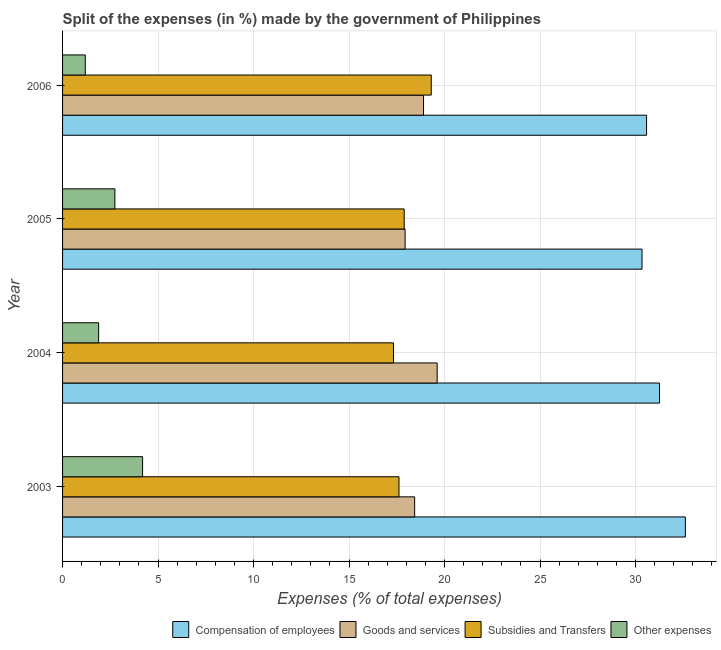How many different coloured bars are there?
Make the answer very short. 4. How many groups of bars are there?
Ensure brevity in your answer.  4. Are the number of bars on each tick of the Y-axis equal?
Give a very brief answer. Yes. What is the percentage of amount spent on goods and services in 2004?
Ensure brevity in your answer.  19.61. Across all years, what is the maximum percentage of amount spent on other expenses?
Offer a terse response. 4.19. Across all years, what is the minimum percentage of amount spent on subsidies?
Give a very brief answer. 17.33. In which year was the percentage of amount spent on compensation of employees maximum?
Make the answer very short. 2003. In which year was the percentage of amount spent on other expenses minimum?
Make the answer very short. 2006. What is the total percentage of amount spent on compensation of employees in the graph?
Make the answer very short. 124.78. What is the difference between the percentage of amount spent on goods and services in 2005 and that in 2006?
Your answer should be compact. -0.96. What is the difference between the percentage of amount spent on compensation of employees in 2003 and the percentage of amount spent on subsidies in 2006?
Your answer should be compact. 13.3. What is the average percentage of amount spent on subsidies per year?
Your answer should be compact. 18.03. In the year 2003, what is the difference between the percentage of amount spent on other expenses and percentage of amount spent on subsidies?
Provide a short and direct response. -13.42. What is the ratio of the percentage of amount spent on compensation of employees in 2003 to that in 2005?
Offer a very short reply. 1.07. What is the difference between the highest and the second highest percentage of amount spent on other expenses?
Keep it short and to the point. 1.45. In how many years, is the percentage of amount spent on other expenses greater than the average percentage of amount spent on other expenses taken over all years?
Your response must be concise. 2. Is the sum of the percentage of amount spent on goods and services in 2005 and 2006 greater than the maximum percentage of amount spent on compensation of employees across all years?
Make the answer very short. Yes. What does the 4th bar from the top in 2006 represents?
Your response must be concise. Compensation of employees. What does the 3rd bar from the bottom in 2006 represents?
Keep it short and to the point. Subsidies and Transfers. How many bars are there?
Give a very brief answer. 16. Are all the bars in the graph horizontal?
Ensure brevity in your answer.  Yes. How many years are there in the graph?
Keep it short and to the point. 4. What is the difference between two consecutive major ticks on the X-axis?
Offer a very short reply. 5. Does the graph contain any zero values?
Provide a succinct answer. No. Does the graph contain grids?
Give a very brief answer. Yes. What is the title of the graph?
Your answer should be compact. Split of the expenses (in %) made by the government of Philippines. Does "Miscellaneous expenses" appear as one of the legend labels in the graph?
Offer a very short reply. No. What is the label or title of the X-axis?
Your response must be concise. Expenses (% of total expenses). What is the label or title of the Y-axis?
Keep it short and to the point. Year. What is the Expenses (% of total expenses) of Compensation of employees in 2003?
Offer a terse response. 32.61. What is the Expenses (% of total expenses) of Goods and services in 2003?
Offer a terse response. 18.44. What is the Expenses (% of total expenses) of Subsidies and Transfers in 2003?
Offer a terse response. 17.62. What is the Expenses (% of total expenses) of Other expenses in 2003?
Provide a succinct answer. 4.19. What is the Expenses (% of total expenses) of Compensation of employees in 2004?
Ensure brevity in your answer.  31.26. What is the Expenses (% of total expenses) of Goods and services in 2004?
Make the answer very short. 19.61. What is the Expenses (% of total expenses) in Subsidies and Transfers in 2004?
Give a very brief answer. 17.33. What is the Expenses (% of total expenses) in Other expenses in 2004?
Provide a succinct answer. 1.89. What is the Expenses (% of total expenses) of Compensation of employees in 2005?
Make the answer very short. 30.34. What is the Expenses (% of total expenses) in Goods and services in 2005?
Provide a succinct answer. 17.94. What is the Expenses (% of total expenses) of Subsidies and Transfers in 2005?
Your answer should be very brief. 17.89. What is the Expenses (% of total expenses) in Other expenses in 2005?
Your response must be concise. 2.74. What is the Expenses (% of total expenses) of Compensation of employees in 2006?
Give a very brief answer. 30.58. What is the Expenses (% of total expenses) of Goods and services in 2006?
Your response must be concise. 18.9. What is the Expenses (% of total expenses) of Subsidies and Transfers in 2006?
Offer a terse response. 19.31. What is the Expenses (% of total expenses) in Other expenses in 2006?
Provide a short and direct response. 1.19. Across all years, what is the maximum Expenses (% of total expenses) in Compensation of employees?
Offer a very short reply. 32.61. Across all years, what is the maximum Expenses (% of total expenses) of Goods and services?
Keep it short and to the point. 19.61. Across all years, what is the maximum Expenses (% of total expenses) in Subsidies and Transfers?
Offer a very short reply. 19.31. Across all years, what is the maximum Expenses (% of total expenses) of Other expenses?
Your response must be concise. 4.19. Across all years, what is the minimum Expenses (% of total expenses) in Compensation of employees?
Your response must be concise. 30.34. Across all years, what is the minimum Expenses (% of total expenses) of Goods and services?
Make the answer very short. 17.94. Across all years, what is the minimum Expenses (% of total expenses) in Subsidies and Transfers?
Make the answer very short. 17.33. Across all years, what is the minimum Expenses (% of total expenses) in Other expenses?
Your response must be concise. 1.19. What is the total Expenses (% of total expenses) in Compensation of employees in the graph?
Keep it short and to the point. 124.78. What is the total Expenses (% of total expenses) in Goods and services in the graph?
Offer a terse response. 74.88. What is the total Expenses (% of total expenses) of Subsidies and Transfers in the graph?
Your answer should be compact. 72.13. What is the total Expenses (% of total expenses) in Other expenses in the graph?
Offer a very short reply. 10.01. What is the difference between the Expenses (% of total expenses) of Compensation of employees in 2003 and that in 2004?
Keep it short and to the point. 1.35. What is the difference between the Expenses (% of total expenses) of Goods and services in 2003 and that in 2004?
Offer a very short reply. -1.18. What is the difference between the Expenses (% of total expenses) of Subsidies and Transfers in 2003 and that in 2004?
Offer a terse response. 0.29. What is the difference between the Expenses (% of total expenses) of Other expenses in 2003 and that in 2004?
Offer a terse response. 2.3. What is the difference between the Expenses (% of total expenses) in Compensation of employees in 2003 and that in 2005?
Keep it short and to the point. 2.27. What is the difference between the Expenses (% of total expenses) in Goods and services in 2003 and that in 2005?
Ensure brevity in your answer.  0.5. What is the difference between the Expenses (% of total expenses) of Subsidies and Transfers in 2003 and that in 2005?
Make the answer very short. -0.27. What is the difference between the Expenses (% of total expenses) of Other expenses in 2003 and that in 2005?
Give a very brief answer. 1.45. What is the difference between the Expenses (% of total expenses) of Compensation of employees in 2003 and that in 2006?
Provide a short and direct response. 2.03. What is the difference between the Expenses (% of total expenses) of Goods and services in 2003 and that in 2006?
Give a very brief answer. -0.46. What is the difference between the Expenses (% of total expenses) in Subsidies and Transfers in 2003 and that in 2006?
Your answer should be very brief. -1.69. What is the difference between the Expenses (% of total expenses) in Other expenses in 2003 and that in 2006?
Give a very brief answer. 3. What is the difference between the Expenses (% of total expenses) of Compensation of employees in 2004 and that in 2005?
Make the answer very short. 0.92. What is the difference between the Expenses (% of total expenses) in Goods and services in 2004 and that in 2005?
Offer a terse response. 1.68. What is the difference between the Expenses (% of total expenses) in Subsidies and Transfers in 2004 and that in 2005?
Your answer should be compact. -0.56. What is the difference between the Expenses (% of total expenses) of Other expenses in 2004 and that in 2005?
Offer a very short reply. -0.85. What is the difference between the Expenses (% of total expenses) in Compensation of employees in 2004 and that in 2006?
Provide a succinct answer. 0.68. What is the difference between the Expenses (% of total expenses) of Goods and services in 2004 and that in 2006?
Provide a succinct answer. 0.71. What is the difference between the Expenses (% of total expenses) in Subsidies and Transfers in 2004 and that in 2006?
Your answer should be compact. -1.98. What is the difference between the Expenses (% of total expenses) in Other expenses in 2004 and that in 2006?
Keep it short and to the point. 0.7. What is the difference between the Expenses (% of total expenses) of Compensation of employees in 2005 and that in 2006?
Give a very brief answer. -0.24. What is the difference between the Expenses (% of total expenses) in Goods and services in 2005 and that in 2006?
Make the answer very short. -0.97. What is the difference between the Expenses (% of total expenses) of Subsidies and Transfers in 2005 and that in 2006?
Your answer should be very brief. -1.42. What is the difference between the Expenses (% of total expenses) of Other expenses in 2005 and that in 2006?
Give a very brief answer. 1.55. What is the difference between the Expenses (% of total expenses) in Compensation of employees in 2003 and the Expenses (% of total expenses) in Goods and services in 2004?
Your answer should be compact. 13. What is the difference between the Expenses (% of total expenses) in Compensation of employees in 2003 and the Expenses (% of total expenses) in Subsidies and Transfers in 2004?
Your answer should be compact. 15.28. What is the difference between the Expenses (% of total expenses) in Compensation of employees in 2003 and the Expenses (% of total expenses) in Other expenses in 2004?
Give a very brief answer. 30.72. What is the difference between the Expenses (% of total expenses) of Goods and services in 2003 and the Expenses (% of total expenses) of Subsidies and Transfers in 2004?
Your response must be concise. 1.11. What is the difference between the Expenses (% of total expenses) of Goods and services in 2003 and the Expenses (% of total expenses) of Other expenses in 2004?
Give a very brief answer. 16.55. What is the difference between the Expenses (% of total expenses) of Subsidies and Transfers in 2003 and the Expenses (% of total expenses) of Other expenses in 2004?
Provide a succinct answer. 15.73. What is the difference between the Expenses (% of total expenses) in Compensation of employees in 2003 and the Expenses (% of total expenses) in Goods and services in 2005?
Your response must be concise. 14.67. What is the difference between the Expenses (% of total expenses) of Compensation of employees in 2003 and the Expenses (% of total expenses) of Subsidies and Transfers in 2005?
Provide a succinct answer. 14.72. What is the difference between the Expenses (% of total expenses) in Compensation of employees in 2003 and the Expenses (% of total expenses) in Other expenses in 2005?
Provide a succinct answer. 29.87. What is the difference between the Expenses (% of total expenses) of Goods and services in 2003 and the Expenses (% of total expenses) of Subsidies and Transfers in 2005?
Provide a succinct answer. 0.55. What is the difference between the Expenses (% of total expenses) of Goods and services in 2003 and the Expenses (% of total expenses) of Other expenses in 2005?
Offer a very short reply. 15.7. What is the difference between the Expenses (% of total expenses) in Subsidies and Transfers in 2003 and the Expenses (% of total expenses) in Other expenses in 2005?
Provide a short and direct response. 14.88. What is the difference between the Expenses (% of total expenses) in Compensation of employees in 2003 and the Expenses (% of total expenses) in Goods and services in 2006?
Offer a terse response. 13.71. What is the difference between the Expenses (% of total expenses) of Compensation of employees in 2003 and the Expenses (% of total expenses) of Subsidies and Transfers in 2006?
Make the answer very short. 13.3. What is the difference between the Expenses (% of total expenses) in Compensation of employees in 2003 and the Expenses (% of total expenses) in Other expenses in 2006?
Your answer should be compact. 31.42. What is the difference between the Expenses (% of total expenses) in Goods and services in 2003 and the Expenses (% of total expenses) in Subsidies and Transfers in 2006?
Ensure brevity in your answer.  -0.87. What is the difference between the Expenses (% of total expenses) of Goods and services in 2003 and the Expenses (% of total expenses) of Other expenses in 2006?
Offer a very short reply. 17.25. What is the difference between the Expenses (% of total expenses) of Subsidies and Transfers in 2003 and the Expenses (% of total expenses) of Other expenses in 2006?
Give a very brief answer. 16.42. What is the difference between the Expenses (% of total expenses) of Compensation of employees in 2004 and the Expenses (% of total expenses) of Goods and services in 2005?
Your answer should be very brief. 13.32. What is the difference between the Expenses (% of total expenses) in Compensation of employees in 2004 and the Expenses (% of total expenses) in Subsidies and Transfers in 2005?
Make the answer very short. 13.37. What is the difference between the Expenses (% of total expenses) in Compensation of employees in 2004 and the Expenses (% of total expenses) in Other expenses in 2005?
Keep it short and to the point. 28.52. What is the difference between the Expenses (% of total expenses) in Goods and services in 2004 and the Expenses (% of total expenses) in Subsidies and Transfers in 2005?
Your response must be concise. 1.73. What is the difference between the Expenses (% of total expenses) in Goods and services in 2004 and the Expenses (% of total expenses) in Other expenses in 2005?
Give a very brief answer. 16.87. What is the difference between the Expenses (% of total expenses) of Subsidies and Transfers in 2004 and the Expenses (% of total expenses) of Other expenses in 2005?
Your answer should be very brief. 14.59. What is the difference between the Expenses (% of total expenses) in Compensation of employees in 2004 and the Expenses (% of total expenses) in Goods and services in 2006?
Make the answer very short. 12.36. What is the difference between the Expenses (% of total expenses) of Compensation of employees in 2004 and the Expenses (% of total expenses) of Subsidies and Transfers in 2006?
Ensure brevity in your answer.  11.95. What is the difference between the Expenses (% of total expenses) of Compensation of employees in 2004 and the Expenses (% of total expenses) of Other expenses in 2006?
Offer a very short reply. 30.07. What is the difference between the Expenses (% of total expenses) of Goods and services in 2004 and the Expenses (% of total expenses) of Subsidies and Transfers in 2006?
Offer a terse response. 0.31. What is the difference between the Expenses (% of total expenses) in Goods and services in 2004 and the Expenses (% of total expenses) in Other expenses in 2006?
Your answer should be compact. 18.42. What is the difference between the Expenses (% of total expenses) of Subsidies and Transfers in 2004 and the Expenses (% of total expenses) of Other expenses in 2006?
Make the answer very short. 16.14. What is the difference between the Expenses (% of total expenses) in Compensation of employees in 2005 and the Expenses (% of total expenses) in Goods and services in 2006?
Your response must be concise. 11.44. What is the difference between the Expenses (% of total expenses) in Compensation of employees in 2005 and the Expenses (% of total expenses) in Subsidies and Transfers in 2006?
Your answer should be compact. 11.03. What is the difference between the Expenses (% of total expenses) of Compensation of employees in 2005 and the Expenses (% of total expenses) of Other expenses in 2006?
Make the answer very short. 29.15. What is the difference between the Expenses (% of total expenses) in Goods and services in 2005 and the Expenses (% of total expenses) in Subsidies and Transfers in 2006?
Offer a very short reply. -1.37. What is the difference between the Expenses (% of total expenses) in Goods and services in 2005 and the Expenses (% of total expenses) in Other expenses in 2006?
Your response must be concise. 16.74. What is the difference between the Expenses (% of total expenses) of Subsidies and Transfers in 2005 and the Expenses (% of total expenses) of Other expenses in 2006?
Make the answer very short. 16.7. What is the average Expenses (% of total expenses) of Compensation of employees per year?
Your answer should be very brief. 31.2. What is the average Expenses (% of total expenses) in Goods and services per year?
Give a very brief answer. 18.72. What is the average Expenses (% of total expenses) in Subsidies and Transfers per year?
Your answer should be very brief. 18.03. What is the average Expenses (% of total expenses) in Other expenses per year?
Your answer should be compact. 2.5. In the year 2003, what is the difference between the Expenses (% of total expenses) of Compensation of employees and Expenses (% of total expenses) of Goods and services?
Give a very brief answer. 14.17. In the year 2003, what is the difference between the Expenses (% of total expenses) of Compensation of employees and Expenses (% of total expenses) of Subsidies and Transfers?
Ensure brevity in your answer.  14.99. In the year 2003, what is the difference between the Expenses (% of total expenses) in Compensation of employees and Expenses (% of total expenses) in Other expenses?
Make the answer very short. 28.42. In the year 2003, what is the difference between the Expenses (% of total expenses) of Goods and services and Expenses (% of total expenses) of Subsidies and Transfers?
Your answer should be compact. 0.82. In the year 2003, what is the difference between the Expenses (% of total expenses) of Goods and services and Expenses (% of total expenses) of Other expenses?
Provide a succinct answer. 14.24. In the year 2003, what is the difference between the Expenses (% of total expenses) in Subsidies and Transfers and Expenses (% of total expenses) in Other expenses?
Offer a very short reply. 13.42. In the year 2004, what is the difference between the Expenses (% of total expenses) of Compensation of employees and Expenses (% of total expenses) of Goods and services?
Keep it short and to the point. 11.64. In the year 2004, what is the difference between the Expenses (% of total expenses) of Compensation of employees and Expenses (% of total expenses) of Subsidies and Transfers?
Make the answer very short. 13.93. In the year 2004, what is the difference between the Expenses (% of total expenses) in Compensation of employees and Expenses (% of total expenses) in Other expenses?
Offer a terse response. 29.37. In the year 2004, what is the difference between the Expenses (% of total expenses) of Goods and services and Expenses (% of total expenses) of Subsidies and Transfers?
Keep it short and to the point. 2.29. In the year 2004, what is the difference between the Expenses (% of total expenses) in Goods and services and Expenses (% of total expenses) in Other expenses?
Ensure brevity in your answer.  17.73. In the year 2004, what is the difference between the Expenses (% of total expenses) of Subsidies and Transfers and Expenses (% of total expenses) of Other expenses?
Make the answer very short. 15.44. In the year 2005, what is the difference between the Expenses (% of total expenses) in Compensation of employees and Expenses (% of total expenses) in Goods and services?
Your answer should be compact. 12.4. In the year 2005, what is the difference between the Expenses (% of total expenses) in Compensation of employees and Expenses (% of total expenses) in Subsidies and Transfers?
Keep it short and to the point. 12.45. In the year 2005, what is the difference between the Expenses (% of total expenses) in Compensation of employees and Expenses (% of total expenses) in Other expenses?
Your answer should be very brief. 27.6. In the year 2005, what is the difference between the Expenses (% of total expenses) in Goods and services and Expenses (% of total expenses) in Subsidies and Transfers?
Keep it short and to the point. 0.05. In the year 2005, what is the difference between the Expenses (% of total expenses) in Goods and services and Expenses (% of total expenses) in Other expenses?
Give a very brief answer. 15.2. In the year 2005, what is the difference between the Expenses (% of total expenses) of Subsidies and Transfers and Expenses (% of total expenses) of Other expenses?
Provide a succinct answer. 15.15. In the year 2006, what is the difference between the Expenses (% of total expenses) in Compensation of employees and Expenses (% of total expenses) in Goods and services?
Your answer should be very brief. 11.68. In the year 2006, what is the difference between the Expenses (% of total expenses) in Compensation of employees and Expenses (% of total expenses) in Subsidies and Transfers?
Your answer should be very brief. 11.27. In the year 2006, what is the difference between the Expenses (% of total expenses) in Compensation of employees and Expenses (% of total expenses) in Other expenses?
Offer a very short reply. 29.39. In the year 2006, what is the difference between the Expenses (% of total expenses) of Goods and services and Expenses (% of total expenses) of Subsidies and Transfers?
Make the answer very short. -0.4. In the year 2006, what is the difference between the Expenses (% of total expenses) in Goods and services and Expenses (% of total expenses) in Other expenses?
Provide a short and direct response. 17.71. In the year 2006, what is the difference between the Expenses (% of total expenses) of Subsidies and Transfers and Expenses (% of total expenses) of Other expenses?
Your answer should be compact. 18.11. What is the ratio of the Expenses (% of total expenses) in Compensation of employees in 2003 to that in 2004?
Make the answer very short. 1.04. What is the ratio of the Expenses (% of total expenses) of Goods and services in 2003 to that in 2004?
Make the answer very short. 0.94. What is the ratio of the Expenses (% of total expenses) in Subsidies and Transfers in 2003 to that in 2004?
Your answer should be very brief. 1.02. What is the ratio of the Expenses (% of total expenses) in Other expenses in 2003 to that in 2004?
Your answer should be compact. 2.22. What is the ratio of the Expenses (% of total expenses) of Compensation of employees in 2003 to that in 2005?
Keep it short and to the point. 1.07. What is the ratio of the Expenses (% of total expenses) of Goods and services in 2003 to that in 2005?
Your answer should be compact. 1.03. What is the ratio of the Expenses (% of total expenses) in Other expenses in 2003 to that in 2005?
Offer a terse response. 1.53. What is the ratio of the Expenses (% of total expenses) of Compensation of employees in 2003 to that in 2006?
Your answer should be compact. 1.07. What is the ratio of the Expenses (% of total expenses) of Goods and services in 2003 to that in 2006?
Make the answer very short. 0.98. What is the ratio of the Expenses (% of total expenses) of Subsidies and Transfers in 2003 to that in 2006?
Offer a very short reply. 0.91. What is the ratio of the Expenses (% of total expenses) in Other expenses in 2003 to that in 2006?
Your answer should be very brief. 3.52. What is the ratio of the Expenses (% of total expenses) in Compensation of employees in 2004 to that in 2005?
Ensure brevity in your answer.  1.03. What is the ratio of the Expenses (% of total expenses) of Goods and services in 2004 to that in 2005?
Make the answer very short. 1.09. What is the ratio of the Expenses (% of total expenses) in Subsidies and Transfers in 2004 to that in 2005?
Make the answer very short. 0.97. What is the ratio of the Expenses (% of total expenses) in Other expenses in 2004 to that in 2005?
Your answer should be very brief. 0.69. What is the ratio of the Expenses (% of total expenses) in Compensation of employees in 2004 to that in 2006?
Keep it short and to the point. 1.02. What is the ratio of the Expenses (% of total expenses) of Goods and services in 2004 to that in 2006?
Provide a short and direct response. 1.04. What is the ratio of the Expenses (% of total expenses) of Subsidies and Transfers in 2004 to that in 2006?
Give a very brief answer. 0.9. What is the ratio of the Expenses (% of total expenses) in Other expenses in 2004 to that in 2006?
Ensure brevity in your answer.  1.59. What is the ratio of the Expenses (% of total expenses) in Goods and services in 2005 to that in 2006?
Give a very brief answer. 0.95. What is the ratio of the Expenses (% of total expenses) of Subsidies and Transfers in 2005 to that in 2006?
Give a very brief answer. 0.93. What is the ratio of the Expenses (% of total expenses) in Other expenses in 2005 to that in 2006?
Keep it short and to the point. 2.3. What is the difference between the highest and the second highest Expenses (% of total expenses) of Compensation of employees?
Offer a very short reply. 1.35. What is the difference between the highest and the second highest Expenses (% of total expenses) of Goods and services?
Ensure brevity in your answer.  0.71. What is the difference between the highest and the second highest Expenses (% of total expenses) of Subsidies and Transfers?
Your response must be concise. 1.42. What is the difference between the highest and the second highest Expenses (% of total expenses) in Other expenses?
Provide a succinct answer. 1.45. What is the difference between the highest and the lowest Expenses (% of total expenses) of Compensation of employees?
Give a very brief answer. 2.27. What is the difference between the highest and the lowest Expenses (% of total expenses) of Goods and services?
Make the answer very short. 1.68. What is the difference between the highest and the lowest Expenses (% of total expenses) of Subsidies and Transfers?
Provide a succinct answer. 1.98. What is the difference between the highest and the lowest Expenses (% of total expenses) of Other expenses?
Your answer should be compact. 3. 